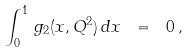<formula> <loc_0><loc_0><loc_500><loc_500>\int _ { 0 } ^ { 1 } \, g _ { 2 } ( x , Q ^ { 2 } ) \, d x \ = \ 0 \, ,</formula> 